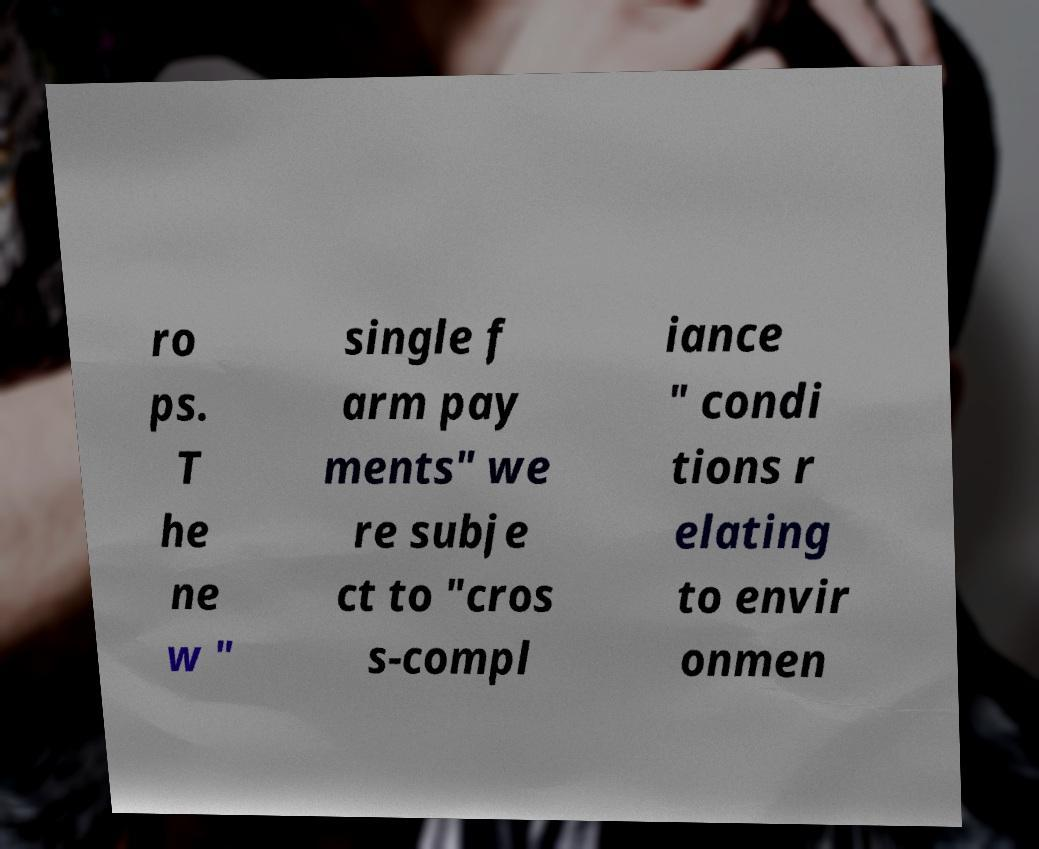Please identify and transcribe the text found in this image. ro ps. T he ne w " single f arm pay ments" we re subje ct to "cros s-compl iance " condi tions r elating to envir onmen 